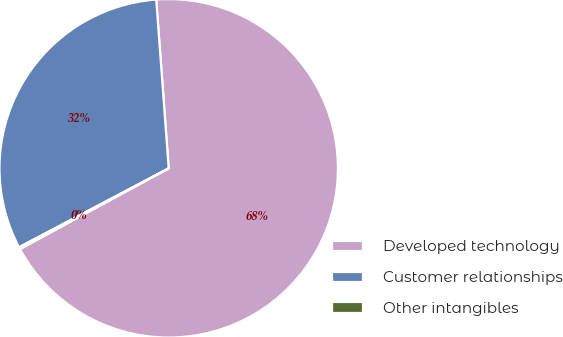Convert chart. <chart><loc_0><loc_0><loc_500><loc_500><pie_chart><fcel>Developed technology<fcel>Customer relationships<fcel>Other intangibles<nl><fcel>68.26%<fcel>31.55%<fcel>0.19%<nl></chart> 